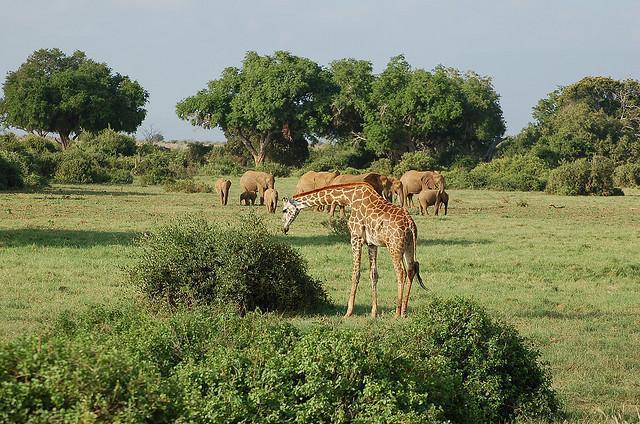How many people are wearing a yellow shirt in the image?
Give a very brief answer. 0. 